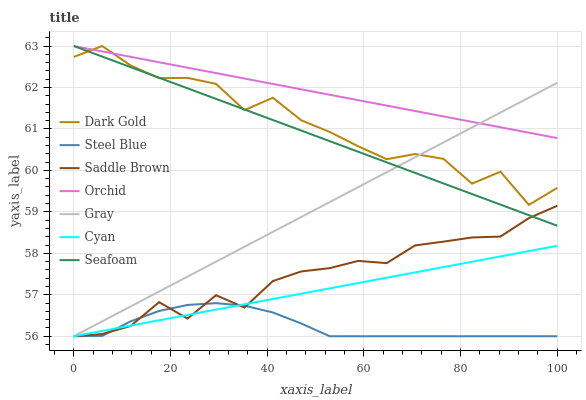Does Steel Blue have the minimum area under the curve?
Answer yes or no. Yes. Does Orchid have the maximum area under the curve?
Answer yes or no. Yes. Does Dark Gold have the minimum area under the curve?
Answer yes or no. No. Does Dark Gold have the maximum area under the curve?
Answer yes or no. No. Is Seafoam the smoothest?
Answer yes or no. Yes. Is Dark Gold the roughest?
Answer yes or no. Yes. Is Steel Blue the smoothest?
Answer yes or no. No. Is Steel Blue the roughest?
Answer yes or no. No. Does Dark Gold have the lowest value?
Answer yes or no. No. Does Orchid have the highest value?
Answer yes or no. Yes. Does Steel Blue have the highest value?
Answer yes or no. No. Is Cyan less than Seafoam?
Answer yes or no. Yes. Is Orchid greater than Cyan?
Answer yes or no. Yes. Does Dark Gold intersect Gray?
Answer yes or no. Yes. Is Dark Gold less than Gray?
Answer yes or no. No. Is Dark Gold greater than Gray?
Answer yes or no. No. Does Cyan intersect Seafoam?
Answer yes or no. No. 